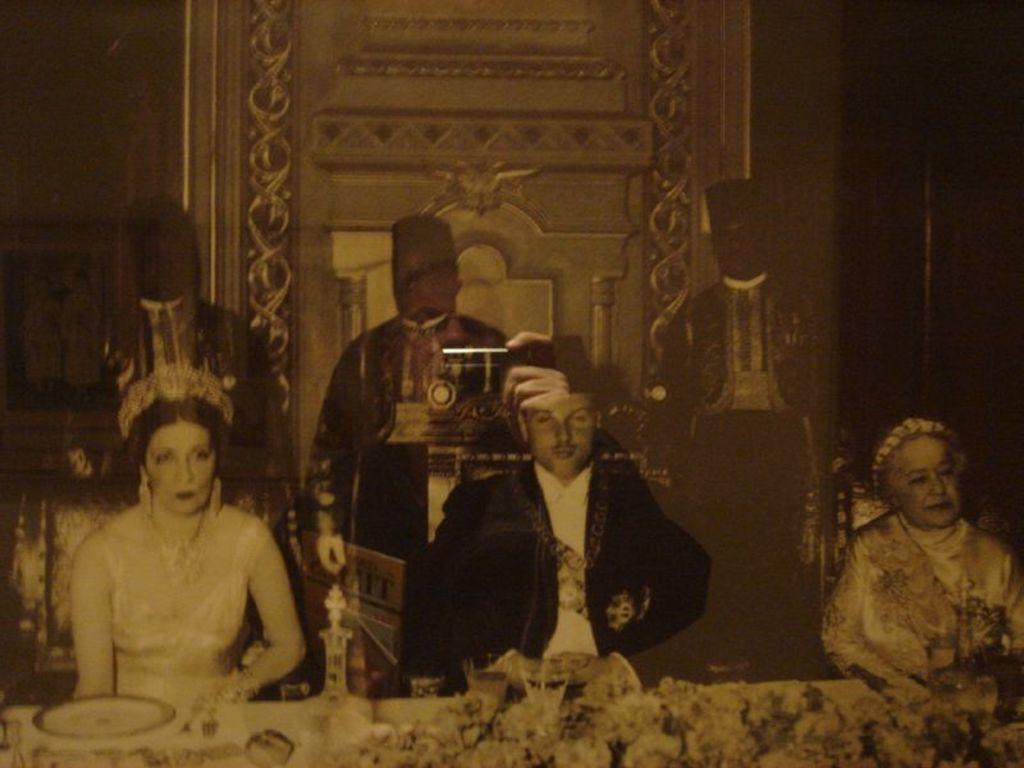Please provide a concise description of this image. In this image in the foreground there are three persons who are sitting on chairs, in front of them there is one table. On the table there are some plates, glasses and some flower bouquets. And in the background there are three persons who are standing and there is a wall and one photo frame. 